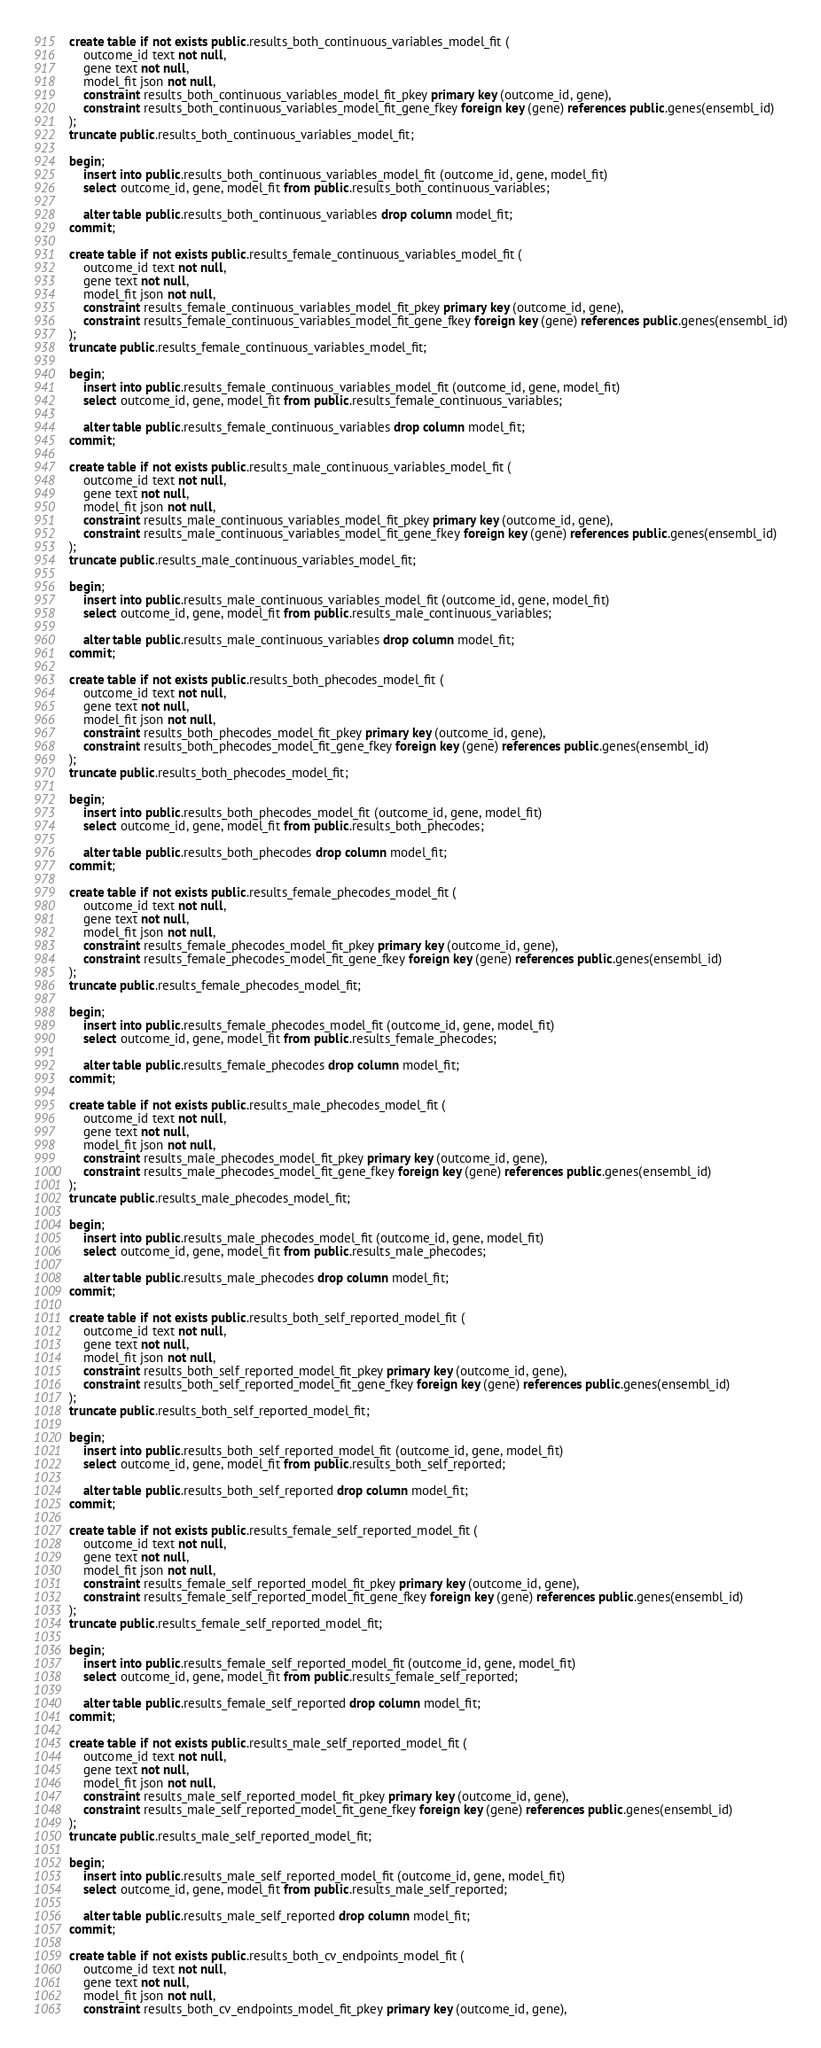Convert code to text. <code><loc_0><loc_0><loc_500><loc_500><_SQL_>create table if not exists public.results_both_continuous_variables_model_fit (
    outcome_id text not null,
    gene text not null,
    model_fit json not null,
    constraint results_both_continuous_variables_model_fit_pkey primary key (outcome_id, gene),
    constraint results_both_continuous_variables_model_fit_gene_fkey foreign key (gene) references public.genes(ensembl_id)
);
truncate public.results_both_continuous_variables_model_fit;
    
begin;
    insert into public.results_both_continuous_variables_model_fit (outcome_id, gene, model_fit)
    select outcome_id, gene, model_fit from public.results_both_continuous_variables;

    alter table public.results_both_continuous_variables drop column model_fit;
commit;
    
create table if not exists public.results_female_continuous_variables_model_fit (
    outcome_id text not null,
    gene text not null,
    model_fit json not null,
    constraint results_female_continuous_variables_model_fit_pkey primary key (outcome_id, gene),
    constraint results_female_continuous_variables_model_fit_gene_fkey foreign key (gene) references public.genes(ensembl_id)
);
truncate public.results_female_continuous_variables_model_fit;
    
begin;
    insert into public.results_female_continuous_variables_model_fit (outcome_id, gene, model_fit)
    select outcome_id, gene, model_fit from public.results_female_continuous_variables;

    alter table public.results_female_continuous_variables drop column model_fit;
commit;
    
create table if not exists public.results_male_continuous_variables_model_fit (
    outcome_id text not null,
    gene text not null,
    model_fit json not null,
    constraint results_male_continuous_variables_model_fit_pkey primary key (outcome_id, gene),
    constraint results_male_continuous_variables_model_fit_gene_fkey foreign key (gene) references public.genes(ensembl_id)
);
truncate public.results_male_continuous_variables_model_fit;
    
begin;
    insert into public.results_male_continuous_variables_model_fit (outcome_id, gene, model_fit)
    select outcome_id, gene, model_fit from public.results_male_continuous_variables;

    alter table public.results_male_continuous_variables drop column model_fit;
commit;
    
create table if not exists public.results_both_phecodes_model_fit (
    outcome_id text not null,
    gene text not null,
    model_fit json not null,
    constraint results_both_phecodes_model_fit_pkey primary key (outcome_id, gene),
    constraint results_both_phecodes_model_fit_gene_fkey foreign key (gene) references public.genes(ensembl_id)
);
truncate public.results_both_phecodes_model_fit;
    
begin;
    insert into public.results_both_phecodes_model_fit (outcome_id, gene, model_fit)
    select outcome_id, gene, model_fit from public.results_both_phecodes;

    alter table public.results_both_phecodes drop column model_fit;
commit;
    
create table if not exists public.results_female_phecodes_model_fit (
    outcome_id text not null,
    gene text not null,
    model_fit json not null,
    constraint results_female_phecodes_model_fit_pkey primary key (outcome_id, gene),
    constraint results_female_phecodes_model_fit_gene_fkey foreign key (gene) references public.genes(ensembl_id)
);
truncate public.results_female_phecodes_model_fit;
    
begin;
    insert into public.results_female_phecodes_model_fit (outcome_id, gene, model_fit)
    select outcome_id, gene, model_fit from public.results_female_phecodes;

    alter table public.results_female_phecodes drop column model_fit;
commit;
    
create table if not exists public.results_male_phecodes_model_fit (
    outcome_id text not null,
    gene text not null,
    model_fit json not null,
    constraint results_male_phecodes_model_fit_pkey primary key (outcome_id, gene),
    constraint results_male_phecodes_model_fit_gene_fkey foreign key (gene) references public.genes(ensembl_id)
);
truncate public.results_male_phecodes_model_fit;
    
begin;
    insert into public.results_male_phecodes_model_fit (outcome_id, gene, model_fit)
    select outcome_id, gene, model_fit from public.results_male_phecodes;

    alter table public.results_male_phecodes drop column model_fit;
commit;
    
create table if not exists public.results_both_self_reported_model_fit (
    outcome_id text not null,
    gene text not null,
    model_fit json not null,
    constraint results_both_self_reported_model_fit_pkey primary key (outcome_id, gene),
    constraint results_both_self_reported_model_fit_gene_fkey foreign key (gene) references public.genes(ensembl_id)
);
truncate public.results_both_self_reported_model_fit;
    
begin;
    insert into public.results_both_self_reported_model_fit (outcome_id, gene, model_fit)
    select outcome_id, gene, model_fit from public.results_both_self_reported;

    alter table public.results_both_self_reported drop column model_fit;
commit;
    
create table if not exists public.results_female_self_reported_model_fit (
    outcome_id text not null,
    gene text not null,
    model_fit json not null,
    constraint results_female_self_reported_model_fit_pkey primary key (outcome_id, gene),
    constraint results_female_self_reported_model_fit_gene_fkey foreign key (gene) references public.genes(ensembl_id)
);
truncate public.results_female_self_reported_model_fit;
    
begin;
    insert into public.results_female_self_reported_model_fit (outcome_id, gene, model_fit)
    select outcome_id, gene, model_fit from public.results_female_self_reported;

    alter table public.results_female_self_reported drop column model_fit;
commit;
    
create table if not exists public.results_male_self_reported_model_fit (
    outcome_id text not null,
    gene text not null,
    model_fit json not null,
    constraint results_male_self_reported_model_fit_pkey primary key (outcome_id, gene),
    constraint results_male_self_reported_model_fit_gene_fkey foreign key (gene) references public.genes(ensembl_id)
);
truncate public.results_male_self_reported_model_fit;
    
begin;
    insert into public.results_male_self_reported_model_fit (outcome_id, gene, model_fit)
    select outcome_id, gene, model_fit from public.results_male_self_reported;

    alter table public.results_male_self_reported drop column model_fit;
commit;
    
create table if not exists public.results_both_cv_endpoints_model_fit (
    outcome_id text not null,
    gene text not null,
    model_fit json not null,
    constraint results_both_cv_endpoints_model_fit_pkey primary key (outcome_id, gene),</code> 